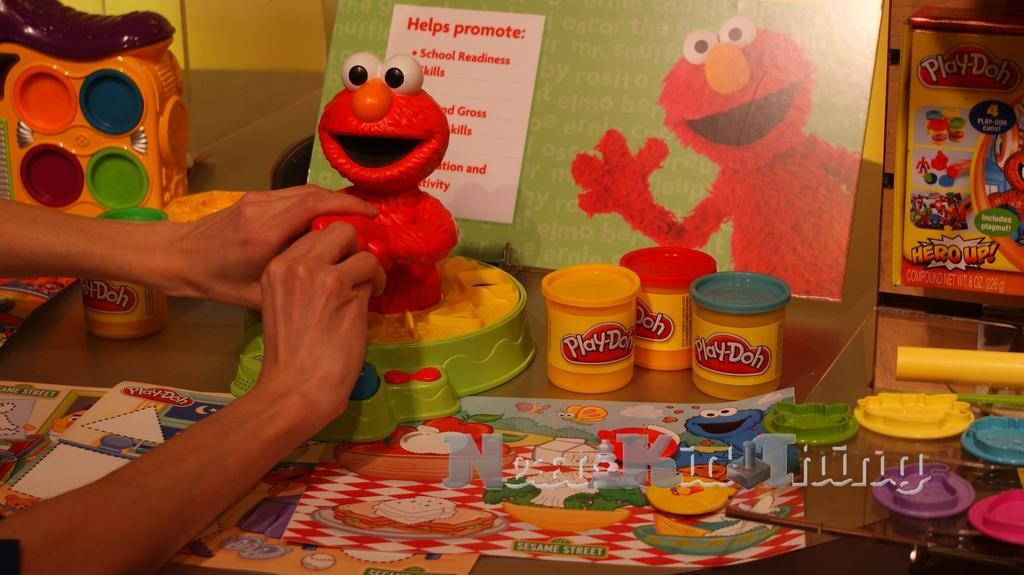Describe this image in one or two sentences. In this picture I can see there is a toy and there is a person holding it. There are few more toys placed on the table and there are few cartons placed on the table. In the backdrop there is a wall. 